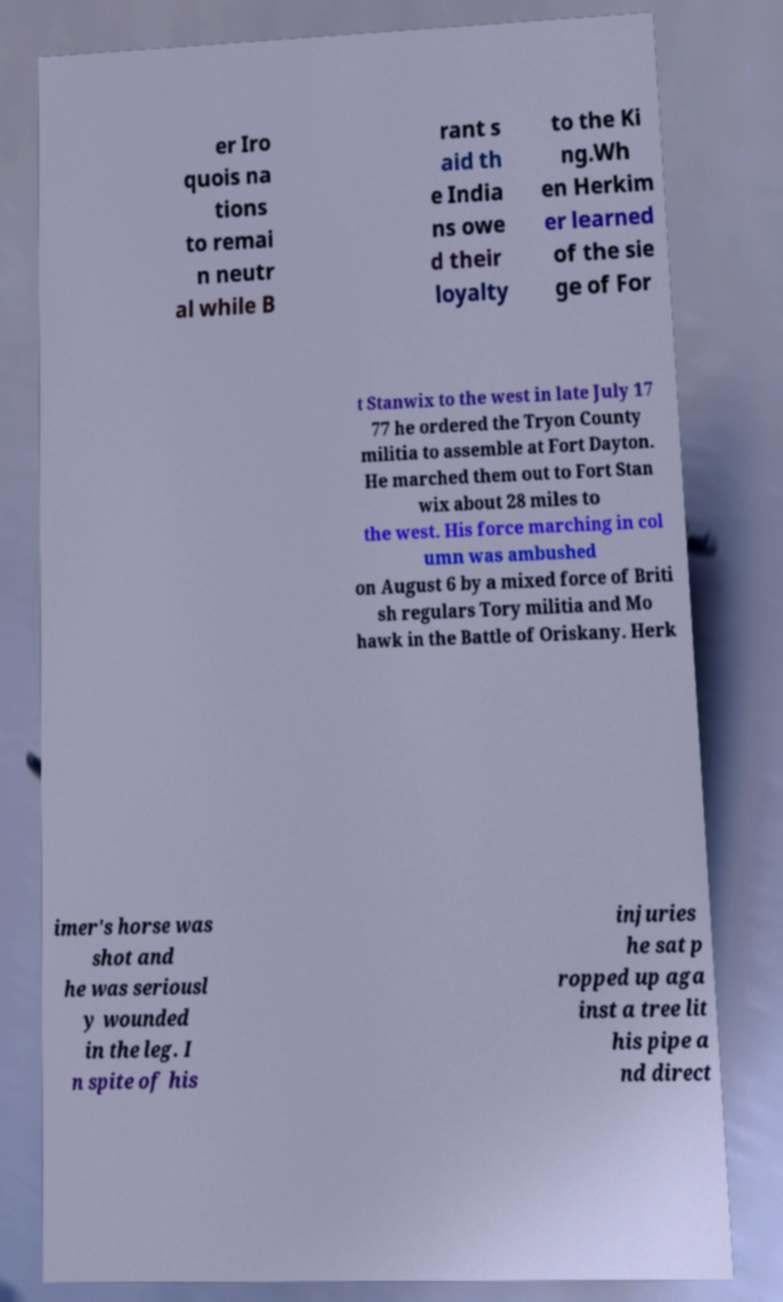What messages or text are displayed in this image? I need them in a readable, typed format. er Iro quois na tions to remai n neutr al while B rant s aid th e India ns owe d their loyalty to the Ki ng.Wh en Herkim er learned of the sie ge of For t Stanwix to the west in late July 17 77 he ordered the Tryon County militia to assemble at Fort Dayton. He marched them out to Fort Stan wix about 28 miles to the west. His force marching in col umn was ambushed on August 6 by a mixed force of Briti sh regulars Tory militia and Mo hawk in the Battle of Oriskany. Herk imer's horse was shot and he was seriousl y wounded in the leg. I n spite of his injuries he sat p ropped up aga inst a tree lit his pipe a nd direct 